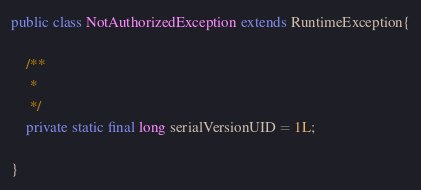<code> <loc_0><loc_0><loc_500><loc_500><_Java_>
public class NotAuthorizedException extends RuntimeException{

	/**
	 * 
	 */
	private static final long serialVersionUID = 1L;

}
</code> 